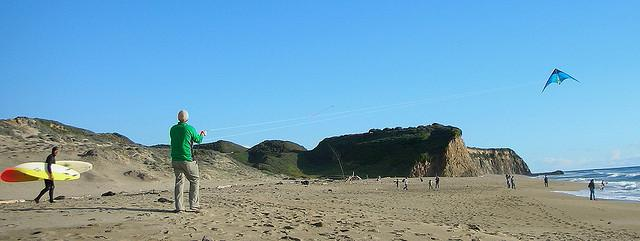What is the man carrying to the water? Please explain your reasoning. surfboards. The man is going surfing and is walking to the water. 